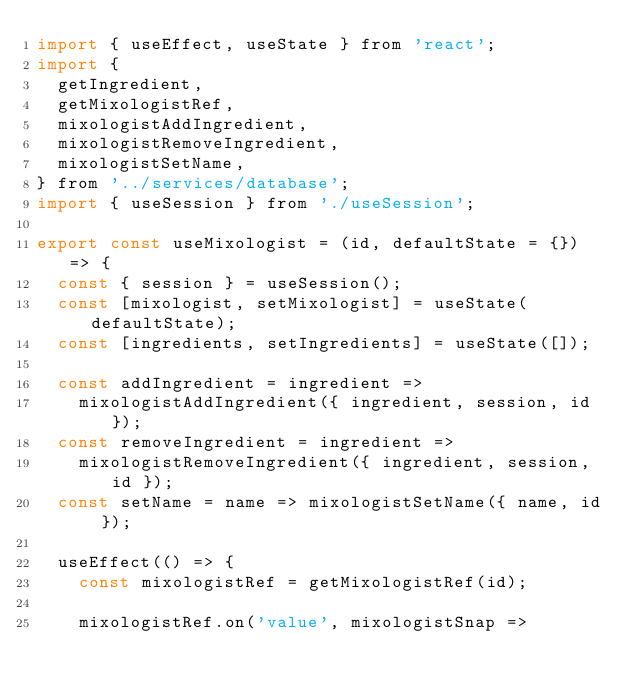Convert code to text. <code><loc_0><loc_0><loc_500><loc_500><_JavaScript_>import { useEffect, useState } from 'react';
import {
  getIngredient,
  getMixologistRef,
  mixologistAddIngredient,
  mixologistRemoveIngredient,
  mixologistSetName,
} from '../services/database';
import { useSession } from './useSession';

export const useMixologist = (id, defaultState = {}) => {
  const { session } = useSession();
  const [mixologist, setMixologist] = useState(defaultState);
  const [ingredients, setIngredients] = useState([]);

  const addIngredient = ingredient =>
    mixologistAddIngredient({ ingredient, session, id });
  const removeIngredient = ingredient =>
    mixologistRemoveIngredient({ ingredient, session, id });
  const setName = name => mixologistSetName({ name, id });

  useEffect(() => {
    const mixologistRef = getMixologistRef(id);

    mixologistRef.on('value', mixologistSnap =></code> 